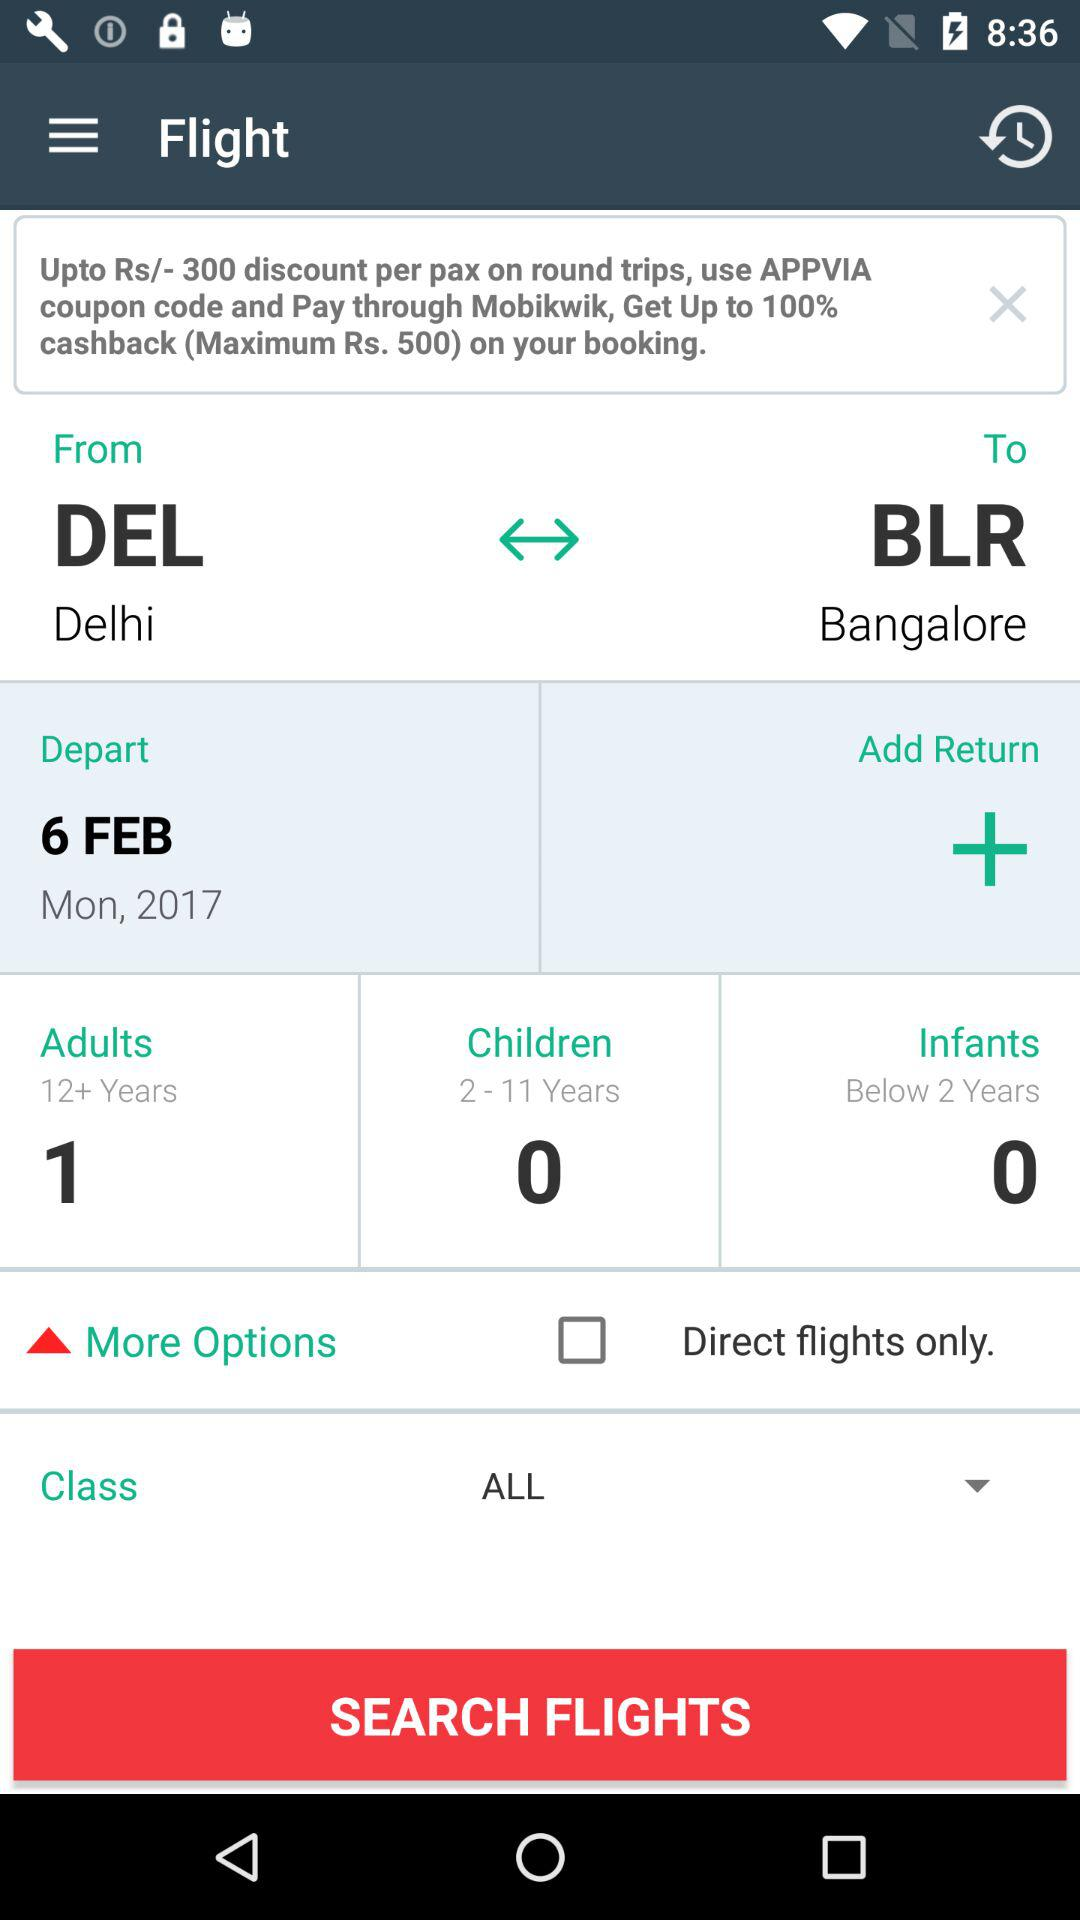From where to where is the flight schedule? The flight schedule is from Delhi to Bangalore. 